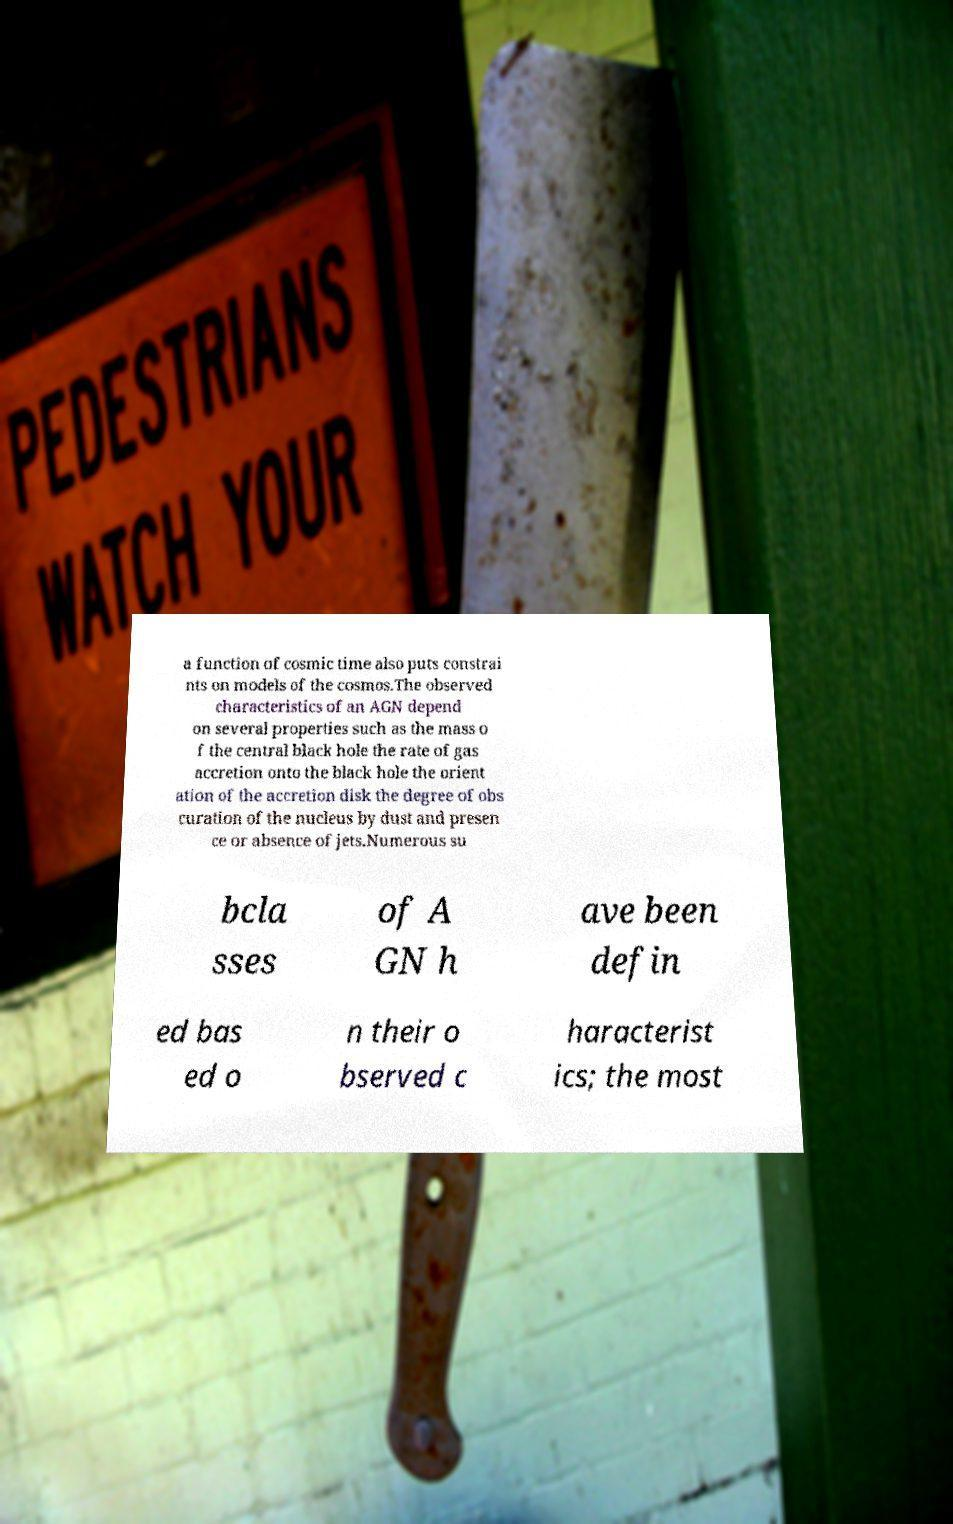Can you accurately transcribe the text from the provided image for me? a function of cosmic time also puts constrai nts on models of the cosmos.The observed characteristics of an AGN depend on several properties such as the mass o f the central black hole the rate of gas accretion onto the black hole the orient ation of the accretion disk the degree of obs curation of the nucleus by dust and presen ce or absence of jets.Numerous su bcla sses of A GN h ave been defin ed bas ed o n their o bserved c haracterist ics; the most 